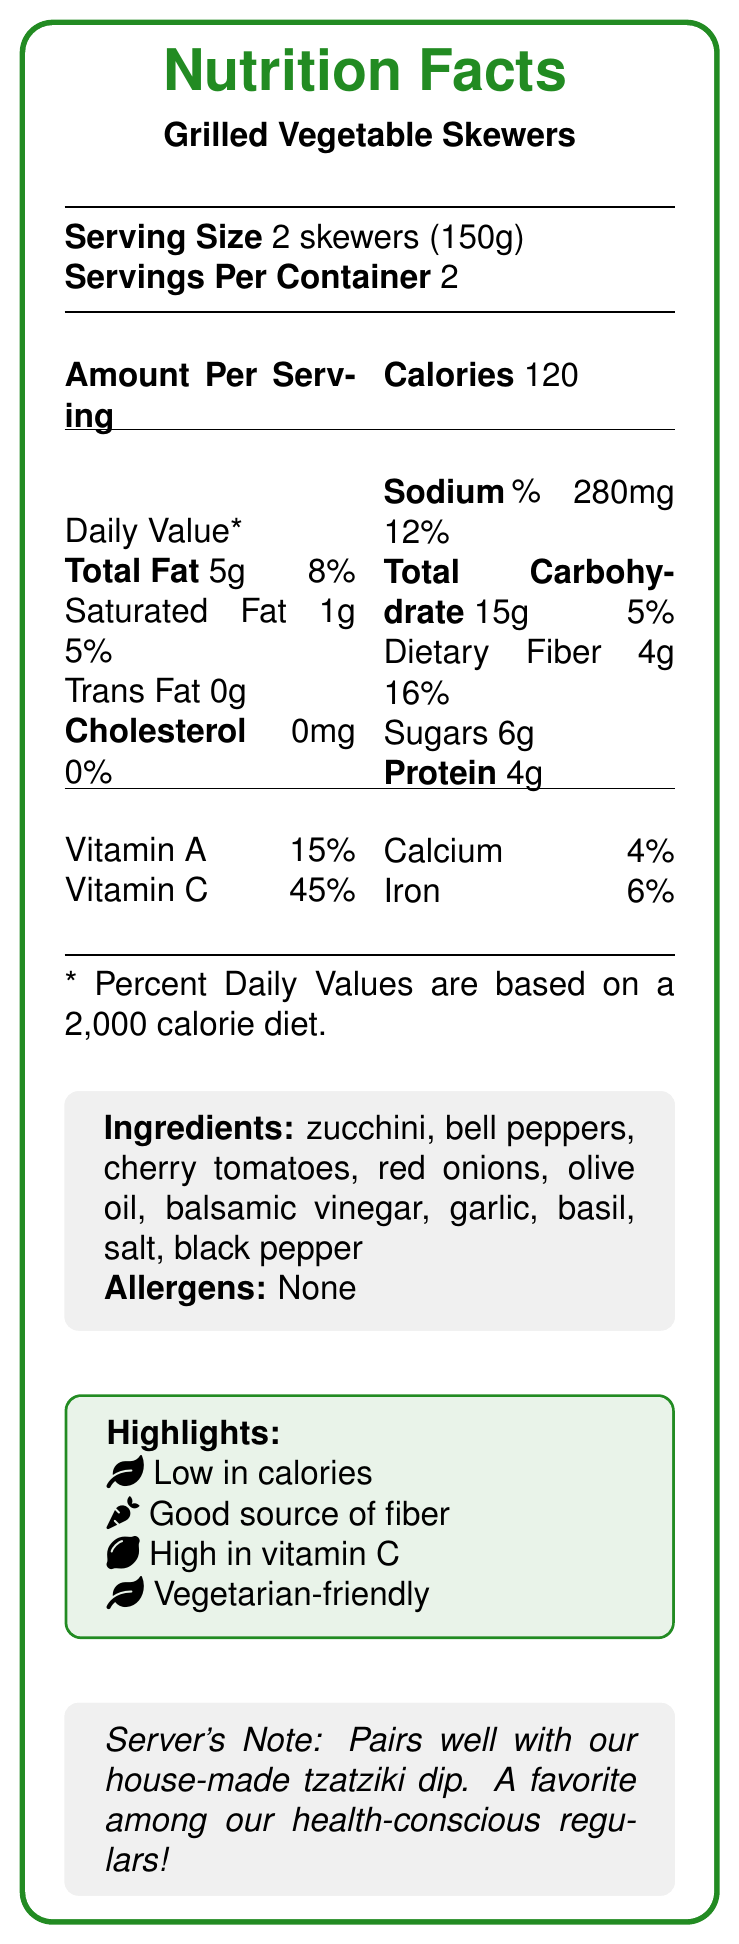what is the serving size? The serving size is explicitly mentioned near the top of the document under "Serving Size."
Answer: 2 skewers (150g) how many calories are in one serving of the Grilled Vegetable Skewers? The document states the calorie content per serving is 120.
Answer: 120 how much dietary fiber is in one serving? The amount of dietary fiber per serving is listed as 4g in the main nutritional content section.
Answer: 4g what is the daily value percentage for Vitamin C? The daily value for Vitamin C is shown as 45% in the vitamin and minerals section.
Answer: 45% name three ingredients included in the Grilled Vegetable Skewers. The ingredients are listed in the document, and these three are part of that list.
Answer: zucchini, bell peppers, cherry tomatoes what is the percentage daily value of total fat per serving? The daily value for total fat per serving is indicated as 8%.
Answer: 8% do the Grilled Vegetable Skewers contain any allergens? The document states "Allergens: None" in the allergens section.
Answer: None what is the sodium content per serving? The sodium content per serving is listed as 280mg.
Answer: 280mg what is the percentage daily value for iron? The daily value for iron is given as 6%.
Answer: 6% what pairs well with the Grilled Vegetable Skewers according to the server's note? The server's note mentions that the skewers pair well with the house-made tzatziki dip.
Answer: house-made tzatziki dip do the Grilled Vegetable Skewers contain trans fat? The document lists the trans fat content as 0g, indicating there is no trans fat.
Answer: No what are the highlighted benefits of choosing this appetizer? The highlighted benefits are listed in the document's highlights section.
Answer: Low in calories, Good source of fiber, High in vitamin C, Vegetarian-friendly based on this document, can you determine the total calories if someone eats the whole container (all servings)? Each serving has 120 calories, and since there are 2 servings per container, the total calories would be 120 * 2 = 240.
Answer: 240 which nutrient has the highest percentage daily value? A. Vitamin A B. Vitamin C C. Calcium D. Iron Vitamin C has the highest percentage daily value at 45%.
Answer: B which of these ingredients is not listed in the Grilled Vegetable Skewers? A. Olive oil B. Balsamic vinegar C. Spinach D. Red onions Spinach is not listed as one of the ingredients.
Answer: C how much protein is in one serving of the Grilled Vegetable Skewers? A. 2g B. 4g C. 6g D. 8g The document states that there are 4g of protein per serving.
Answer: B are the Grilled Vegetable Skewers high in calories? (Yes/No) The document highlights that this appetizer is "Low in calories."
Answer: No describe the main idea of the document. This document is primarily designed to give consumers a clear understanding of the nutritional content and benefits of the appetizer, along with some serving suggestions and preparation details.
Answer: The document provides the nutrition facts for Grilled Vegetable Skewers, including details on serving size, calories, nutrients, ingredients, allergens, health highlights, and server notes. what are the preparation time and presentation details for the Grilled Vegetable Skewers according to the server notes? The details given in the initial data are not present in the visual document format provided.
Answer: Not enough information 